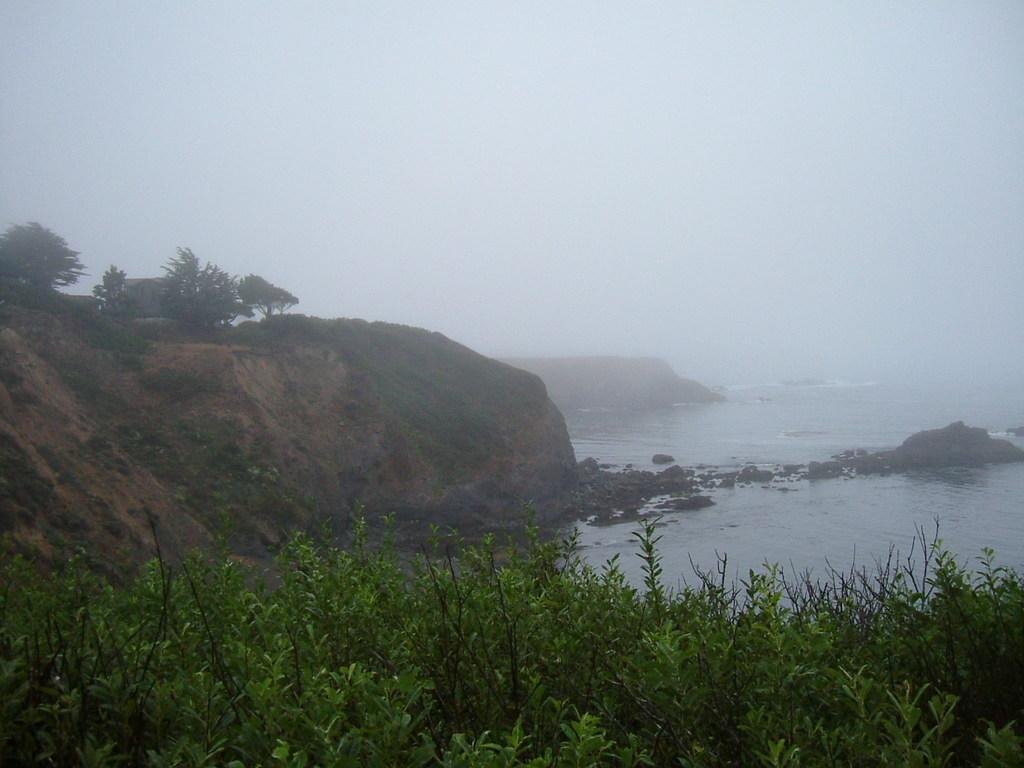What type of living organisms can be seen in the image? Plants and trees are visible in the image. What is the primary element in which the plants are situated? There is water visible in the image, and the plants are situated in it. What type of vegetation is observable in the image? Trees are present in the image. What type of pen can be seen floating in the water in the image? There is no pen present in the image; it only features plants and trees situated in water. 